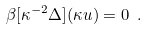Convert formula to latex. <formula><loc_0><loc_0><loc_500><loc_500>\beta [ \kappa ^ { - 2 } \Delta ] ( \kappa u ) = 0 \ .</formula> 